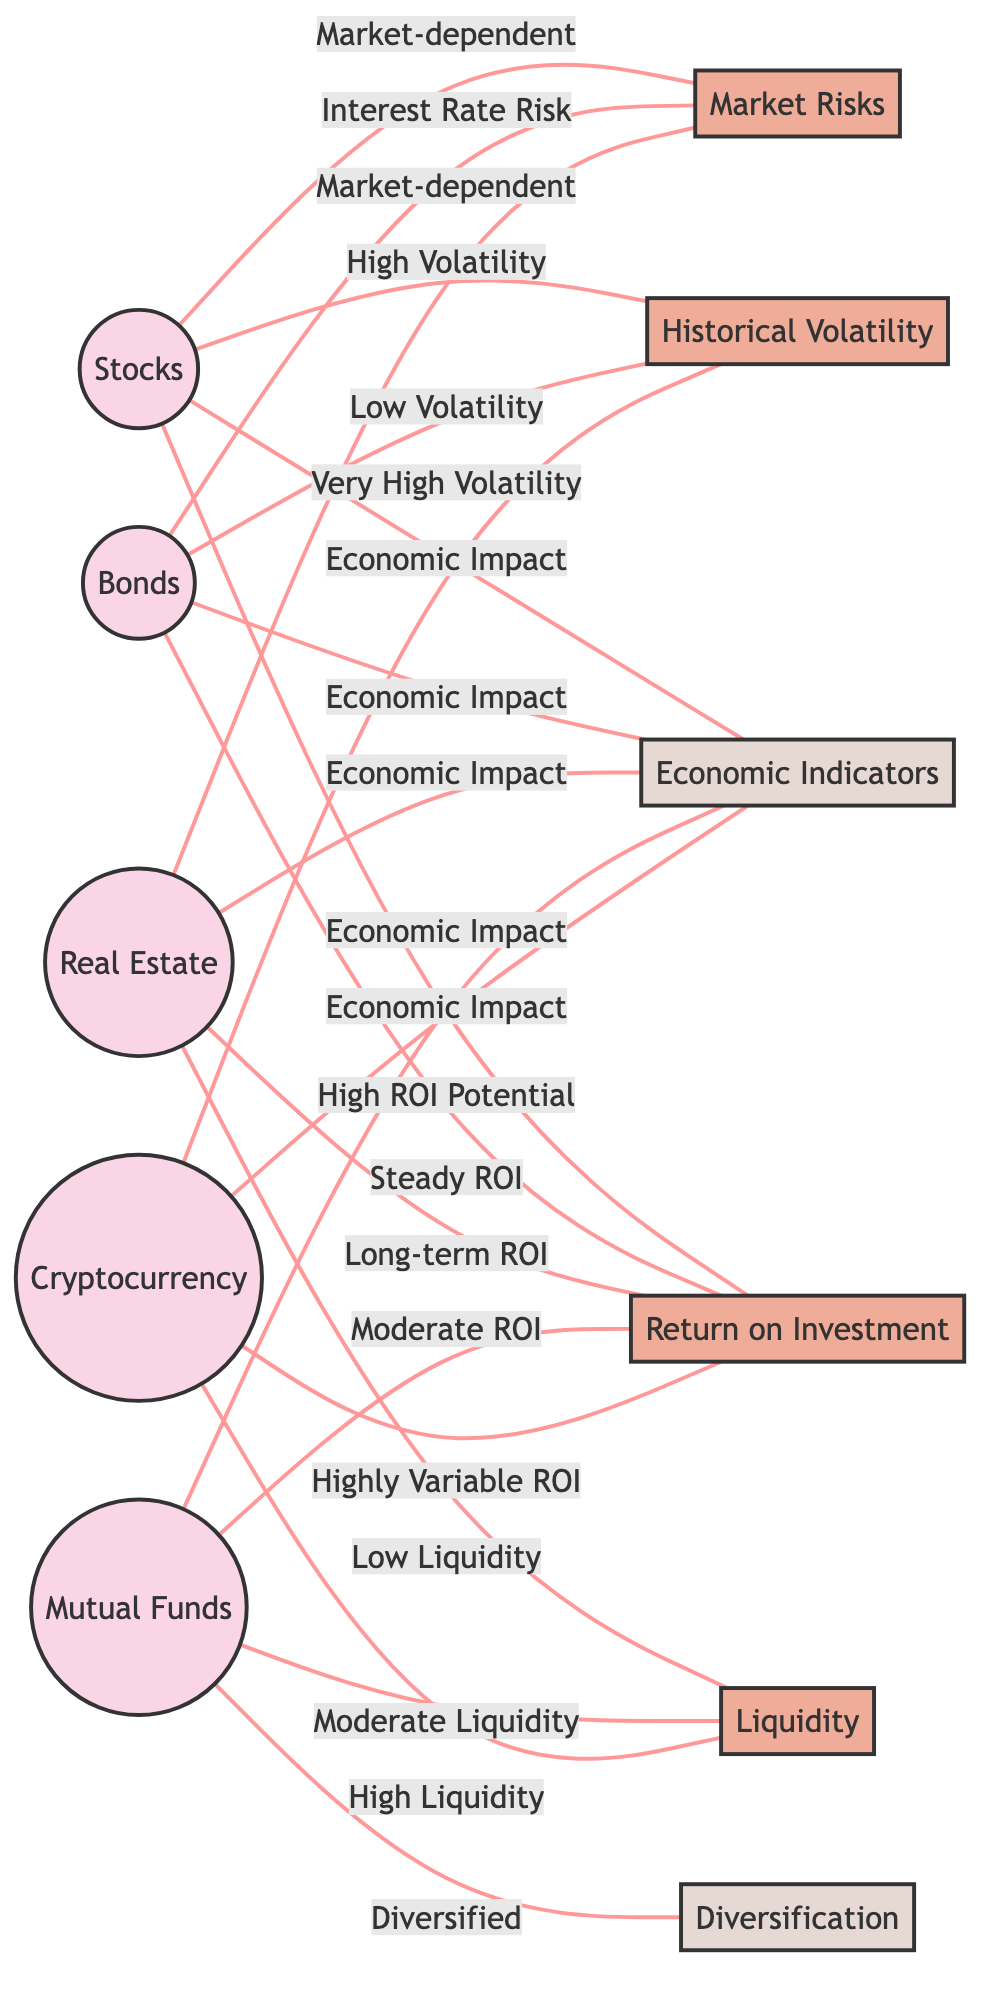What investment type is linked to low volatility? In the diagram, Bonds are directly connected to the Historical Volatility node with the label "Low Volatility." This indicates that bonds exhibit a low level of volatility relative to other investment types.
Answer: Bonds Which investment type has very high volatility? The diagram shows Cryptocurrency connected to the Historical Volatility node labeled "Very High Volatility," denoting that it is characterized by significant fluctuations in value.
Answer: Cryptocurrency How many different investment types are represented in the diagram? The diagram lists five investment types: Stocks, Bonds, Real Estate, Mutual Funds, and Cryptocurrency. By counting these nodes, we find the total amounts to five distinct types.
Answer: 5 What is the liquidity level associated with real estate? The Real Estate node connects to the Liquidity node with the label "Low Liquidity." This relationship indicates that investing in real estate tends to have lower liquidity compared to other investment types.
Answer: Low Liquidity Which investment type is associated with the highest ROI potential? The Stocks node is connected to the ROI node with the label "High ROI Potential," implying that stocks offer the best return on investment potential among the listed types.
Answer: High ROI Potential How many edges connect investment types to the return on investment node? In the diagram, there are five edges connected to the ROI node from the investment types: Stocks, Bonds, Real Estate, Mutual Funds, and Cryptocurrency. This indicates that all five investment types have a relationship with return on investment.
Answer: 5 What risk type is associated with bonds? The diagram indicates that Bonds are linked to the Market Risks node with the label "Interest Rate Risk," meaning this is a significant risk factor for bond investments.
Answer: Interest Rate Risk Which investment type is labeled as diversified? The Mutual Funds node is connected to the Diversification node with the label "Diversified," indicating that mutual funds are characterized by a diversified investment approach.
Answer: Diversified What do all investment types have in common regarding economic impact? All five investment types—Stocks, Bonds, Real Estate, Mutual Funds, and Cryptocurrency—connect to the Economic Indicators node, each labeled with "Economic Impact," suggesting that they are all influenced by economic factors.
Answer: Economic Impact 